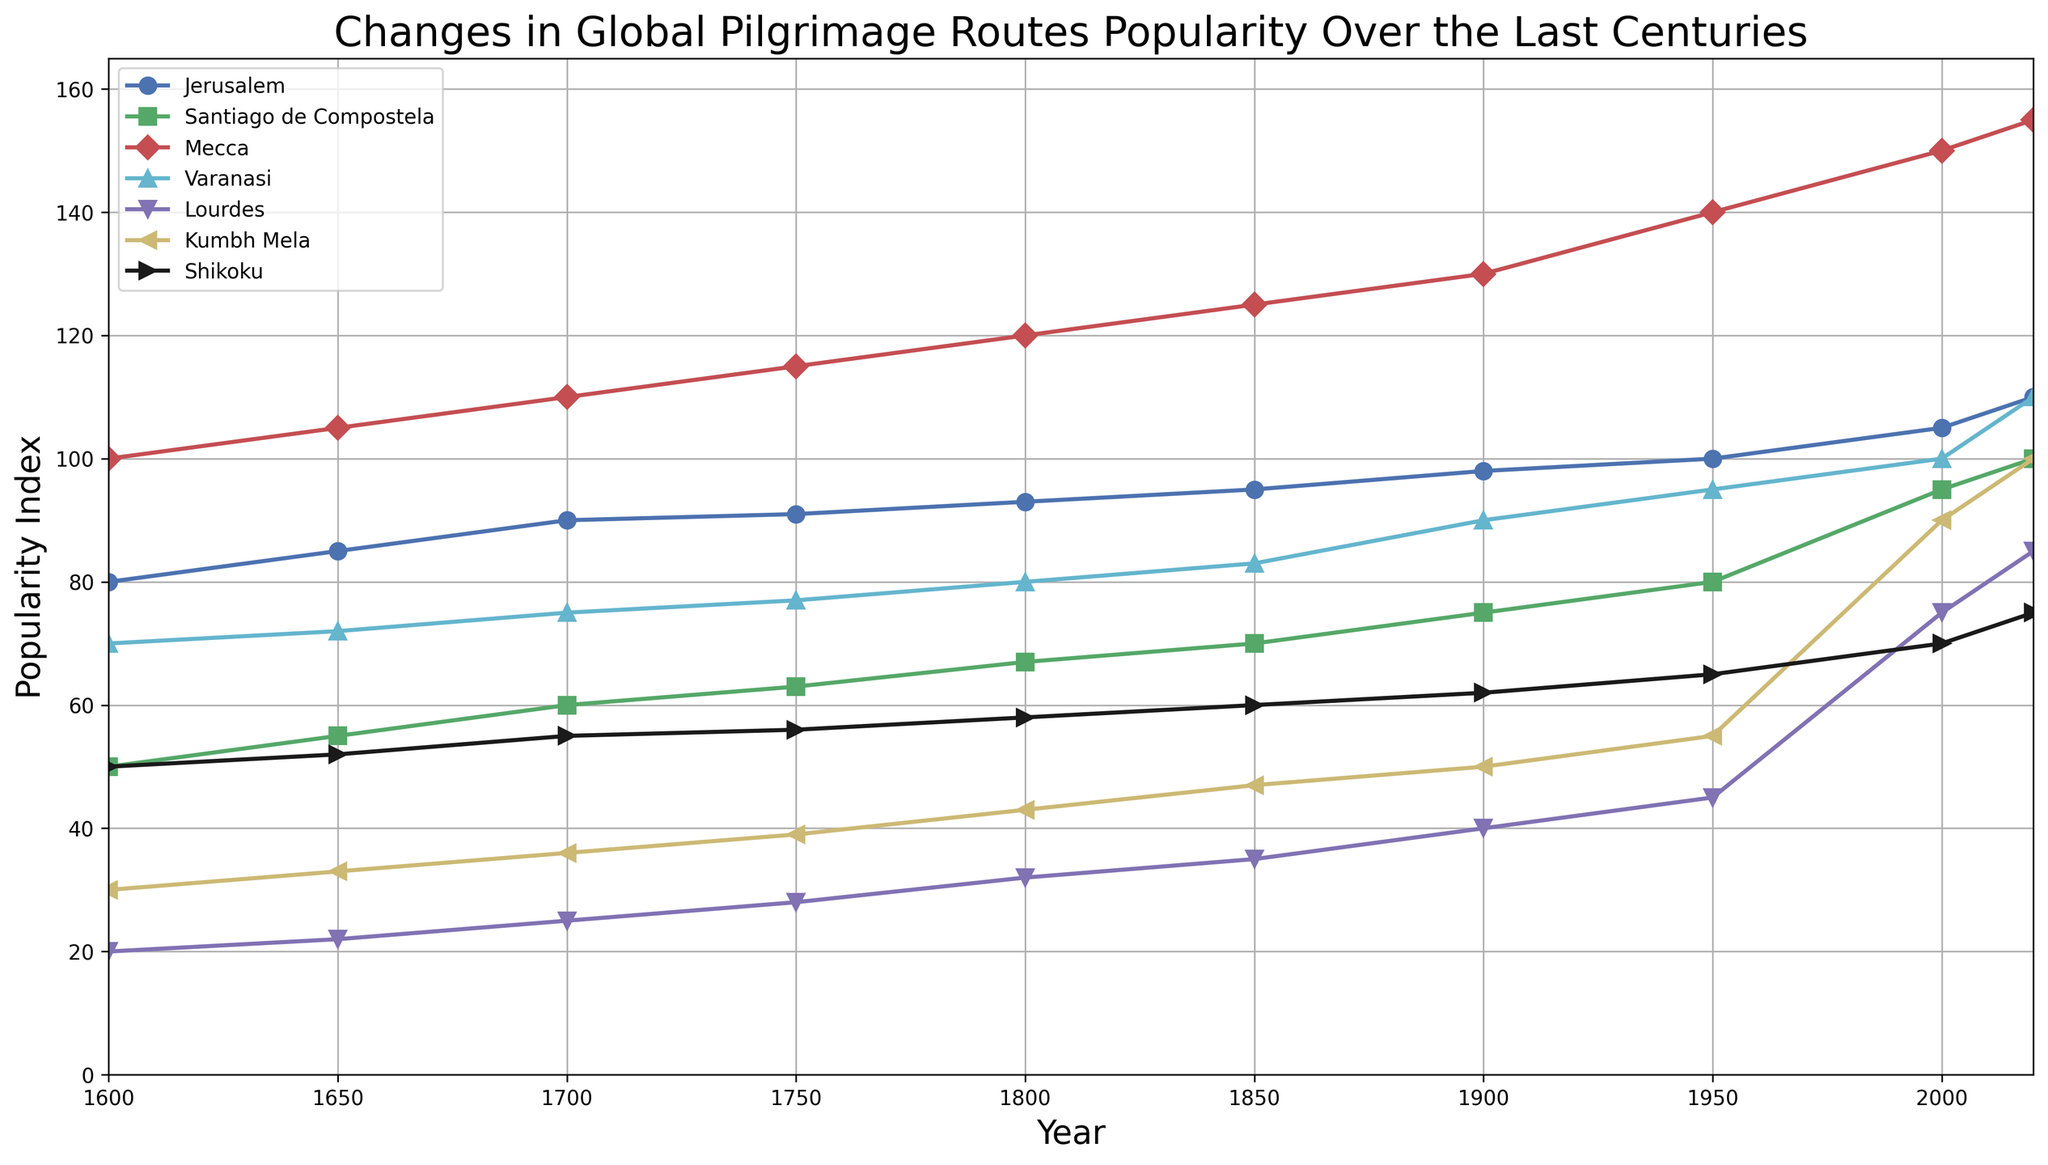Which pilgrimage route shows the highest popularity index in 2020? To identify the highest popularity index in 2020, look at the values on the y-axis for the year 2020. The Mecca line reaches the highest point.
Answer: Mecca Which pilgrimage route had the lowest popularity in 1600? In the year 1600, compare the starting points of all routes on the y-axis. Lourdes has the lowest initial value.
Answer: Lourdes Between 1750 and 1800, which pilgrimage route experienced the largest increase in popularity? Calculate the difference in popularity index for each route between 1750 and 1800. Mecca increased from 115 to 120, which is the largest increase among all routes.
Answer: Mecca How did the popularity of Jerusalem change from 1650 to 1900? To understand the change in popularity, subtract the value of 1650 from that in 1900 for Jerusalem. The difference is 98 - 85. This means the popularity increased by 13.
Answer: Increased by 13 Looking at the color codes, which pilgrimage route is represented by the green line, and how did its popularity change over time? The green line represents Santiago de Compostela. Observing the line from left to right, starting at 50 in 1600 and ending at 100 in 2020, shows a steady increase in popularity.
Answer: Santiago de Compostela, increased steadily Which pilgrimage routes had similar popularity trends between 1900 and 1950? Compare the slopes between 1900 and 1950. Both Varanasi and Lourdes lines show a similar upward trend.
Answer: Varanasi and Lourdes In 2020, is the popularity of Kumbh Mela higher than that of Lourdes? Check the y-axis value for Kumbh Mela and Lourdes in 2020. Kumbh Mela's value is 100, and Lourdes' value is 85, so Kumbh Mela is higher.
Answer: Yes If you combine the popularity indices of Shikoku and Santiago de Compostela for the year 2000, what is the total? Add the values of Shikoku (70) and Santiago de Compostela (95) in 2000. The total is 70 + 95.
Answer: 165 Throughout the centuries, which pilgrimage route shows the least amount of change in popularity index value? To determine this, observe the lines for the smallest slope or least vertical movement. Shikoku maintains a relatively flat line, indicating the least change.
Answer: Shikoku What is the average popularity index of Mecca over all the years presented in the data? Sum the Mecca values (100, 105, 110, 115, 120, 125, 130, 140, 150, 155) which gives 1250. There are 10 data points, so divide by 10.
Answer: 125 